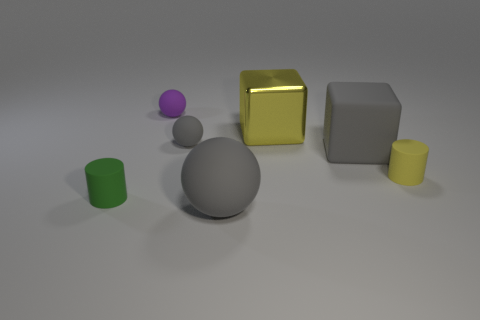If these objects were part of a game, how might the game be played? If we imagine these objects as part of a game, the game could involve spatial reasoning and strategy. For instance, players might take turns moving objects on a grid, aiming to align shapes in a specific order or pattern. The different sizes and shapes of the objects would introduce varying levels of complexity and challenge to the game. 